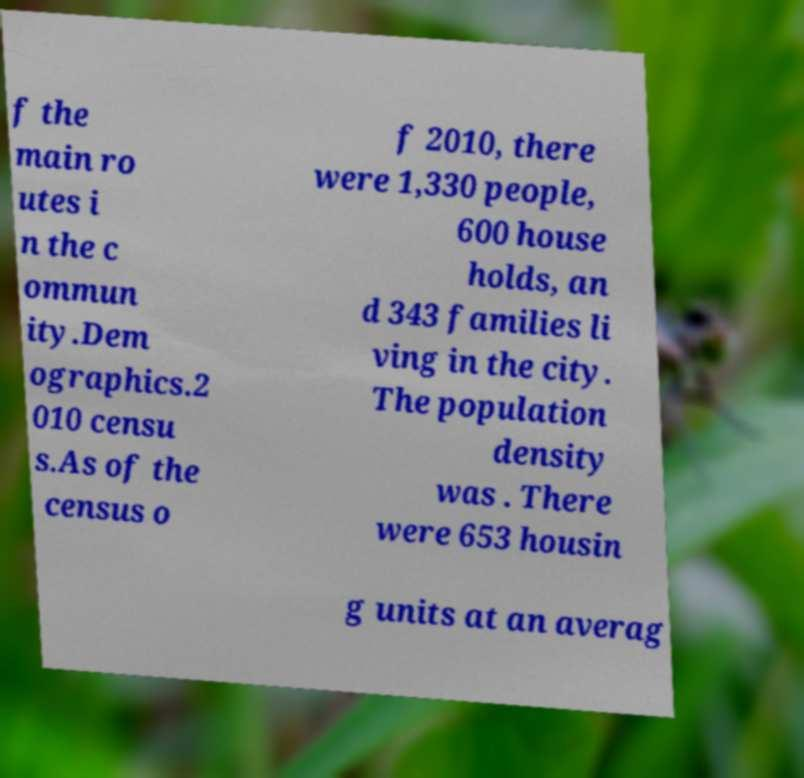Can you accurately transcribe the text from the provided image for me? f the main ro utes i n the c ommun ity.Dem ographics.2 010 censu s.As of the census o f 2010, there were 1,330 people, 600 house holds, an d 343 families li ving in the city. The population density was . There were 653 housin g units at an averag 